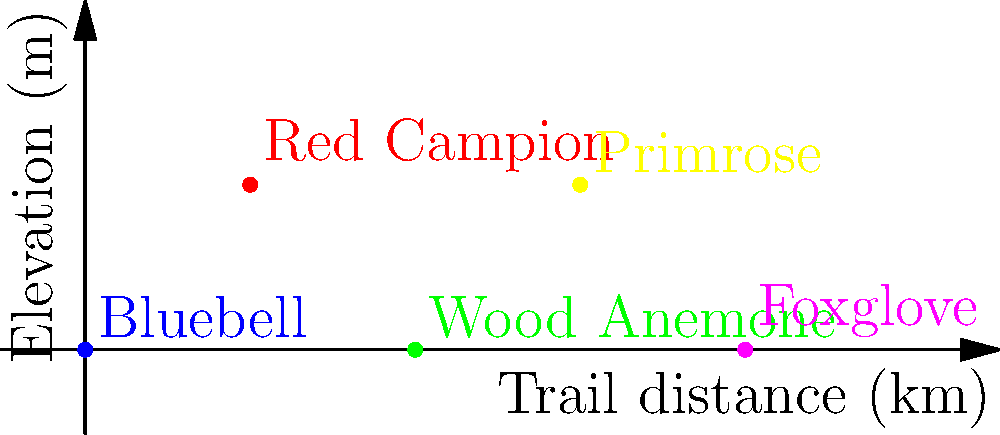Along a 4km nature trail in a British woodland, you encounter five different plant species. Which of these flowering plants typically blooms earliest in the spring? To answer this question, we need to consider the typical blooming times of the plants shown on the trail:

1. Bluebell: Usually blooms from late April to May.
2. Red Campion: Typically flowers from May to September.
3. Wood Anemone: One of the earliest spring flowers, blooming from March to May.
4. Primrose: An early spring flower that can bloom as early as December but typically flowers from March to May.
5. Foxglove: Generally blooms from June to September.

Among these plants, the Primrose and Wood Anemone are known for being early spring bloomers. However, the Primrose can sometimes start flowering as early as December in mild winters, making it the earliest potential bloomer in this group.
Answer: Primrose 